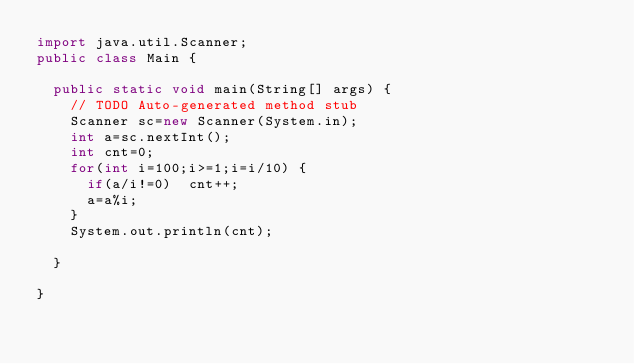<code> <loc_0><loc_0><loc_500><loc_500><_Java_>import java.util.Scanner;
public class Main {

	public static void main(String[] args) {
		// TODO Auto-generated method stub
		Scanner sc=new Scanner(System.in);
		int a=sc.nextInt();
		int cnt=0;
		for(int i=100;i>=1;i=i/10) {
			if(a/i!=0)	cnt++;
			a=a%i;
		}
		System.out.println(cnt);

	}

}</code> 